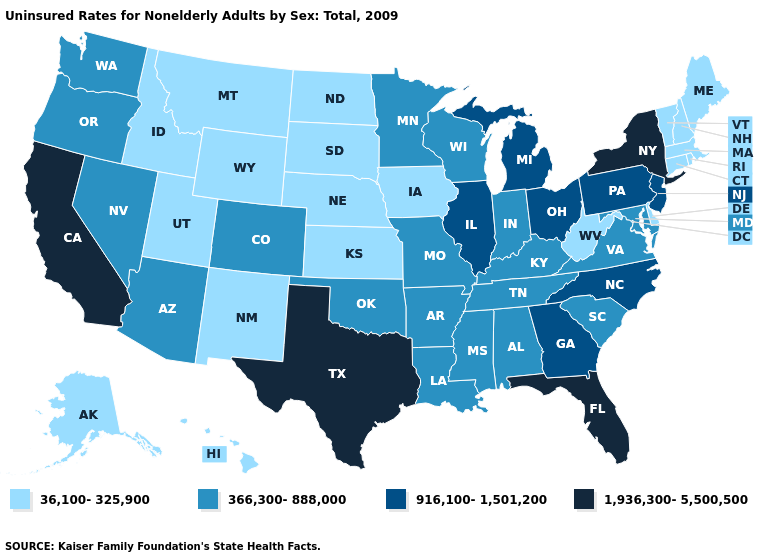Does New York have the highest value in the Northeast?
Give a very brief answer. Yes. What is the value of Maryland?
Concise answer only. 366,300-888,000. Among the states that border Louisiana , does Texas have the lowest value?
Give a very brief answer. No. What is the value of Idaho?
Concise answer only. 36,100-325,900. Among the states that border Indiana , which have the lowest value?
Answer briefly. Kentucky. Does Nebraska have the lowest value in the MidWest?
Keep it brief. Yes. Does Colorado have the highest value in the West?
Answer briefly. No. Name the states that have a value in the range 1,936,300-5,500,500?
Write a very short answer. California, Florida, New York, Texas. Which states have the lowest value in the USA?
Be succinct. Alaska, Connecticut, Delaware, Hawaii, Idaho, Iowa, Kansas, Maine, Massachusetts, Montana, Nebraska, New Hampshire, New Mexico, North Dakota, Rhode Island, South Dakota, Utah, Vermont, West Virginia, Wyoming. What is the value of Montana?
Write a very short answer. 36,100-325,900. Among the states that border Oregon , which have the highest value?
Quick response, please. California. Name the states that have a value in the range 916,100-1,501,200?
Concise answer only. Georgia, Illinois, Michigan, New Jersey, North Carolina, Ohio, Pennsylvania. What is the highest value in the USA?
Short answer required. 1,936,300-5,500,500. Name the states that have a value in the range 916,100-1,501,200?
Give a very brief answer. Georgia, Illinois, Michigan, New Jersey, North Carolina, Ohio, Pennsylvania. Name the states that have a value in the range 36,100-325,900?
Short answer required. Alaska, Connecticut, Delaware, Hawaii, Idaho, Iowa, Kansas, Maine, Massachusetts, Montana, Nebraska, New Hampshire, New Mexico, North Dakota, Rhode Island, South Dakota, Utah, Vermont, West Virginia, Wyoming. 